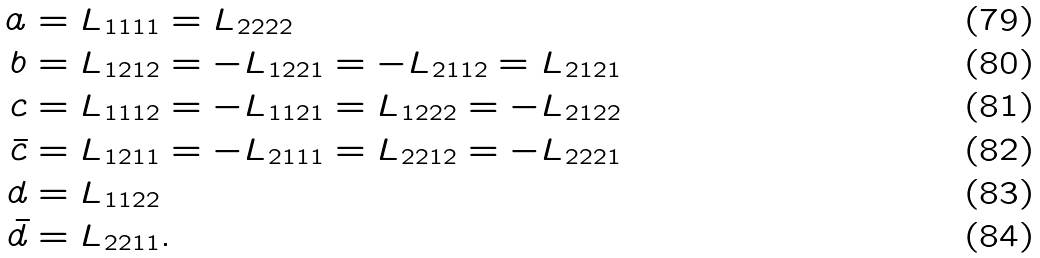Convert formula to latex. <formula><loc_0><loc_0><loc_500><loc_500>a & = L _ { 1 1 1 1 } = L _ { 2 2 2 2 } \\ b & = L _ { 1 2 1 2 } = - L _ { 1 2 2 1 } = - L _ { 2 1 1 2 } = L _ { 2 1 2 1 } \\ c & = L _ { 1 1 1 2 } = - L _ { 1 1 2 1 } = L _ { 1 2 2 2 } = - L _ { 2 1 2 2 } \\ \bar { c } & = L _ { 1 2 1 1 } = - L _ { 2 1 1 1 } = L _ { 2 2 1 2 } = - L _ { 2 2 2 1 } \\ d & = L _ { 1 1 2 2 } \\ \bar { d } & = L _ { 2 2 1 1 } .</formula> 